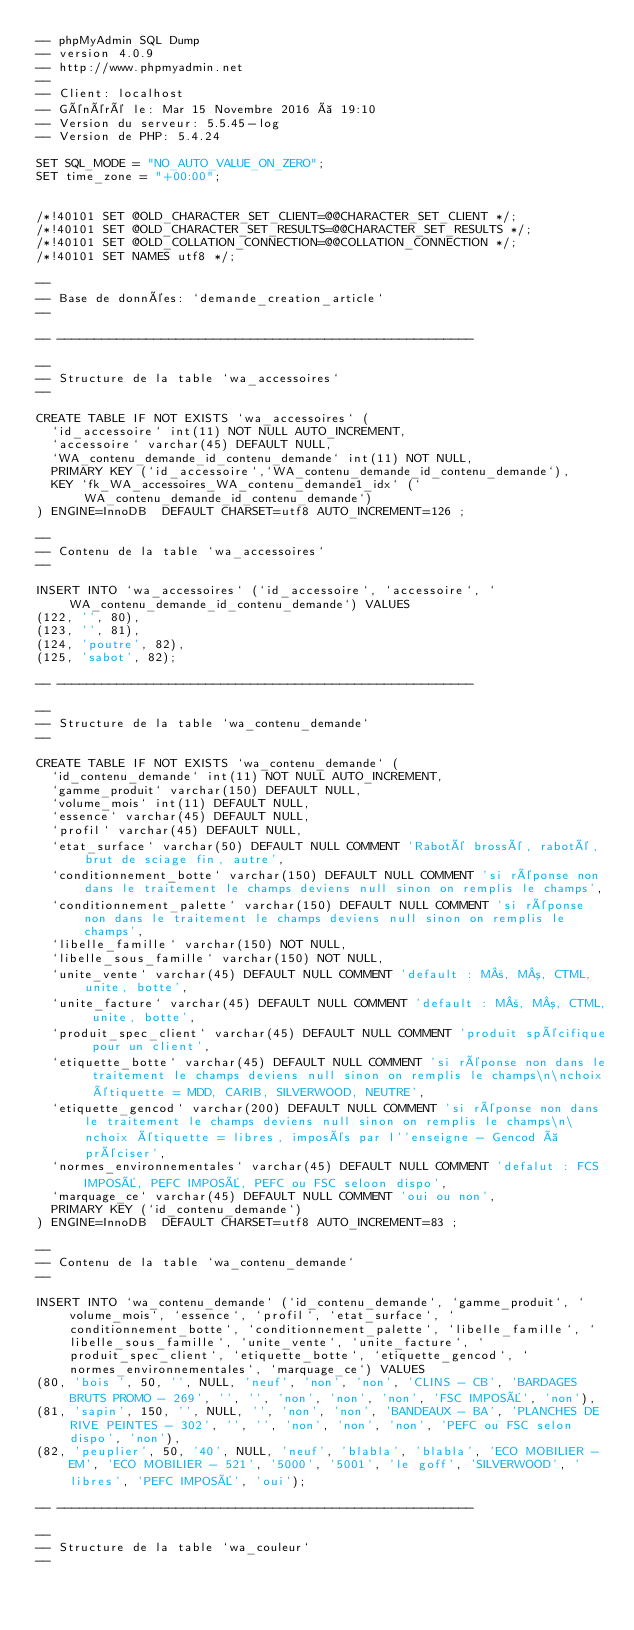<code> <loc_0><loc_0><loc_500><loc_500><_SQL_>-- phpMyAdmin SQL Dump
-- version 4.0.9
-- http://www.phpmyadmin.net
--
-- Client: localhost
-- Généré le: Mar 15 Novembre 2016 à 19:10
-- Version du serveur: 5.5.45-log
-- Version de PHP: 5.4.24

SET SQL_MODE = "NO_AUTO_VALUE_ON_ZERO";
SET time_zone = "+00:00";


/*!40101 SET @OLD_CHARACTER_SET_CLIENT=@@CHARACTER_SET_CLIENT */;
/*!40101 SET @OLD_CHARACTER_SET_RESULTS=@@CHARACTER_SET_RESULTS */;
/*!40101 SET @OLD_COLLATION_CONNECTION=@@COLLATION_CONNECTION */;
/*!40101 SET NAMES utf8 */;

--
-- Base de données: `demande_creation_article`
--

-- --------------------------------------------------------

--
-- Structure de la table `wa_accessoires`
--

CREATE TABLE IF NOT EXISTS `wa_accessoires` (
  `id_accessoire` int(11) NOT NULL AUTO_INCREMENT,
  `accessoire` varchar(45) DEFAULT NULL,
  `WA_contenu_demande_id_contenu_demande` int(11) NOT NULL,
  PRIMARY KEY (`id_accessoire`,`WA_contenu_demande_id_contenu_demande`),
  KEY `fk_WA_accessoires_WA_contenu_demande1_idx` (`WA_contenu_demande_id_contenu_demande`)
) ENGINE=InnoDB  DEFAULT CHARSET=utf8 AUTO_INCREMENT=126 ;

--
-- Contenu de la table `wa_accessoires`
--

INSERT INTO `wa_accessoires` (`id_accessoire`, `accessoire`, `WA_contenu_demande_id_contenu_demande`) VALUES
(122, '', 80),
(123, '', 81),
(124, 'poutre', 82),
(125, 'sabot', 82);

-- --------------------------------------------------------

--
-- Structure de la table `wa_contenu_demande`
--

CREATE TABLE IF NOT EXISTS `wa_contenu_demande` (
  `id_contenu_demande` int(11) NOT NULL AUTO_INCREMENT,
  `gamme_produit` varchar(150) DEFAULT NULL,
  `volume_mois` int(11) DEFAULT NULL,
  `essence` varchar(45) DEFAULT NULL,
  `profil` varchar(45) DEFAULT NULL,
  `etat_surface` varchar(50) DEFAULT NULL COMMENT 'Raboté brossé, raboté, brut de sciage fin, autre',
  `conditionnement_botte` varchar(150) DEFAULT NULL COMMENT 'si réponse non dans le traitement le champs deviens null sinon on remplis le champs',
  `conditionnement_palette` varchar(150) DEFAULT NULL COMMENT 'si réponse non dans le traitement le champs deviens null sinon on remplis le champs',
  `libelle_famille` varchar(150) NOT NULL,
  `libelle_sous_famille` varchar(150) NOT NULL,
  `unite_vente` varchar(45) DEFAULT NULL COMMENT 'default : M², M³, CTML, unite, botte',
  `unite_facture` varchar(45) DEFAULT NULL COMMENT 'default : M², M³, CTML, unite, botte',
  `produit_spec_client` varchar(45) DEFAULT NULL COMMENT 'produit spécifique pour un client',
  `etiquette_botte` varchar(45) DEFAULT NULL COMMENT 'si réponse non dans le traitement le champs deviens null sinon on remplis le champs\n\nchoix étiquette = MDD, CARIB, SILVERWOOD, NEUTRE',
  `etiquette_gencod` varchar(200) DEFAULT NULL COMMENT 'si réponse non dans le traitement le champs deviens null sinon on remplis le champs\n\nchoix étiquette = libres, imposés par l''enseigne - Gencod à préciser',
  `normes_environnementales` varchar(45) DEFAULT NULL COMMENT 'defalut : FCS IMPOSÉ, PEFC IMPOSÉ, PEFC ou FSC seloon dispo',
  `marquage_ce` varchar(45) DEFAULT NULL COMMENT 'oui ou non',
  PRIMARY KEY (`id_contenu_demande`)
) ENGINE=InnoDB  DEFAULT CHARSET=utf8 AUTO_INCREMENT=83 ;

--
-- Contenu de la table `wa_contenu_demande`
--

INSERT INTO `wa_contenu_demande` (`id_contenu_demande`, `gamme_produit`, `volume_mois`, `essence`, `profil`, `etat_surface`, `conditionnement_botte`, `conditionnement_palette`, `libelle_famille`, `libelle_sous_famille`, `unite_vente`, `unite_facture`, `produit_spec_client`, `etiquette_botte`, `etiquette_gencod`, `normes_environnementales`, `marquage_ce`) VALUES
(80, 'bois ', 50, '', NULL, 'neuf', 'non', 'non', 'CLINS - CB', 'BARDAGES BRUTS PROMO - 269', '', '', 'non', 'non', 'non', 'FSC IMPOSÉ', 'non'),
(81, 'sapin', 150, '', NULL, '', 'non', 'non', 'BANDEAUX - BA', 'PLANCHES DE RIVE PEINTES - 302', '', '', 'non', 'non', 'non', 'PEFC ou FSC selon dispo', 'non'),
(82, 'peuplier', 50, '40', NULL, 'neuf', 'blabla', 'blabla', 'ECO MOBILIER - EM', 'ECO MOBILIER - 521', '5000', '5001', 'le goff', 'SILVERWOOD', 'libres', 'PEFC IMPOSÉ', 'oui');

-- --------------------------------------------------------

--
-- Structure de la table `wa_couleur`
--
</code> 